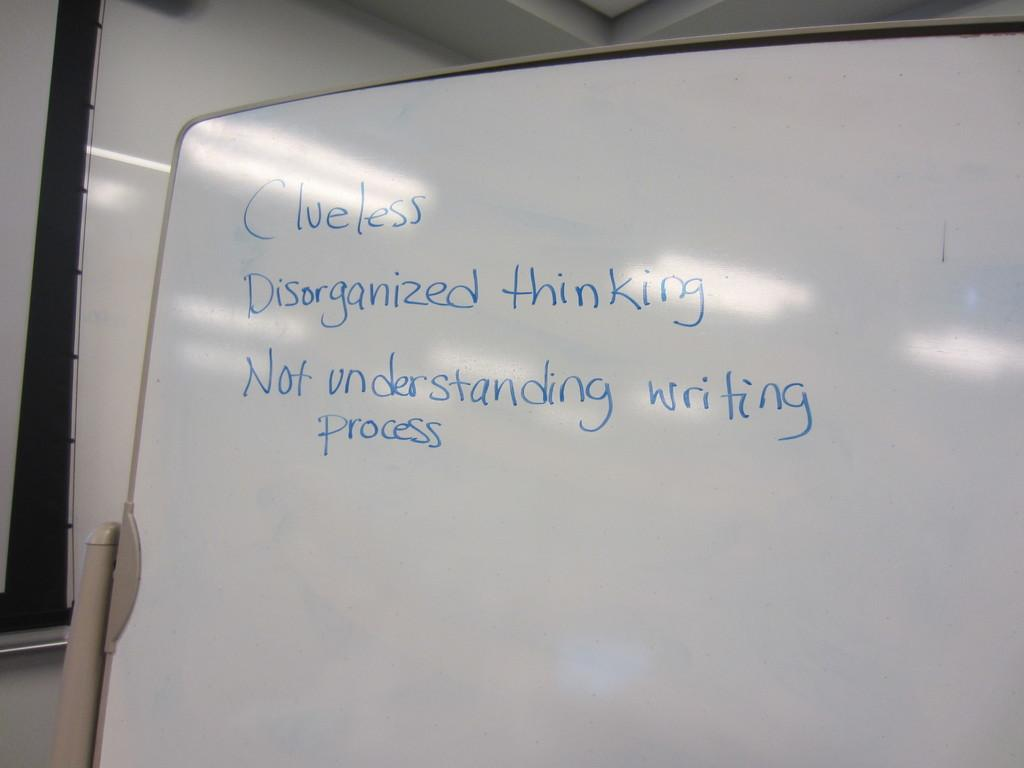<image>
Offer a succinct explanation of the picture presented. A white board with blue writing on it and that contains three negative items. 